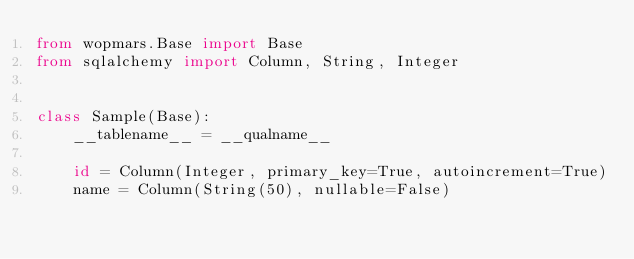Convert code to text. <code><loc_0><loc_0><loc_500><loc_500><_Python_>from wopmars.Base import Base
from sqlalchemy import Column, String, Integer


class Sample(Base):
    __tablename__ = __qualname__

    id = Column(Integer, primary_key=True, autoincrement=True)
    name = Column(String(50), nullable=False)
</code> 